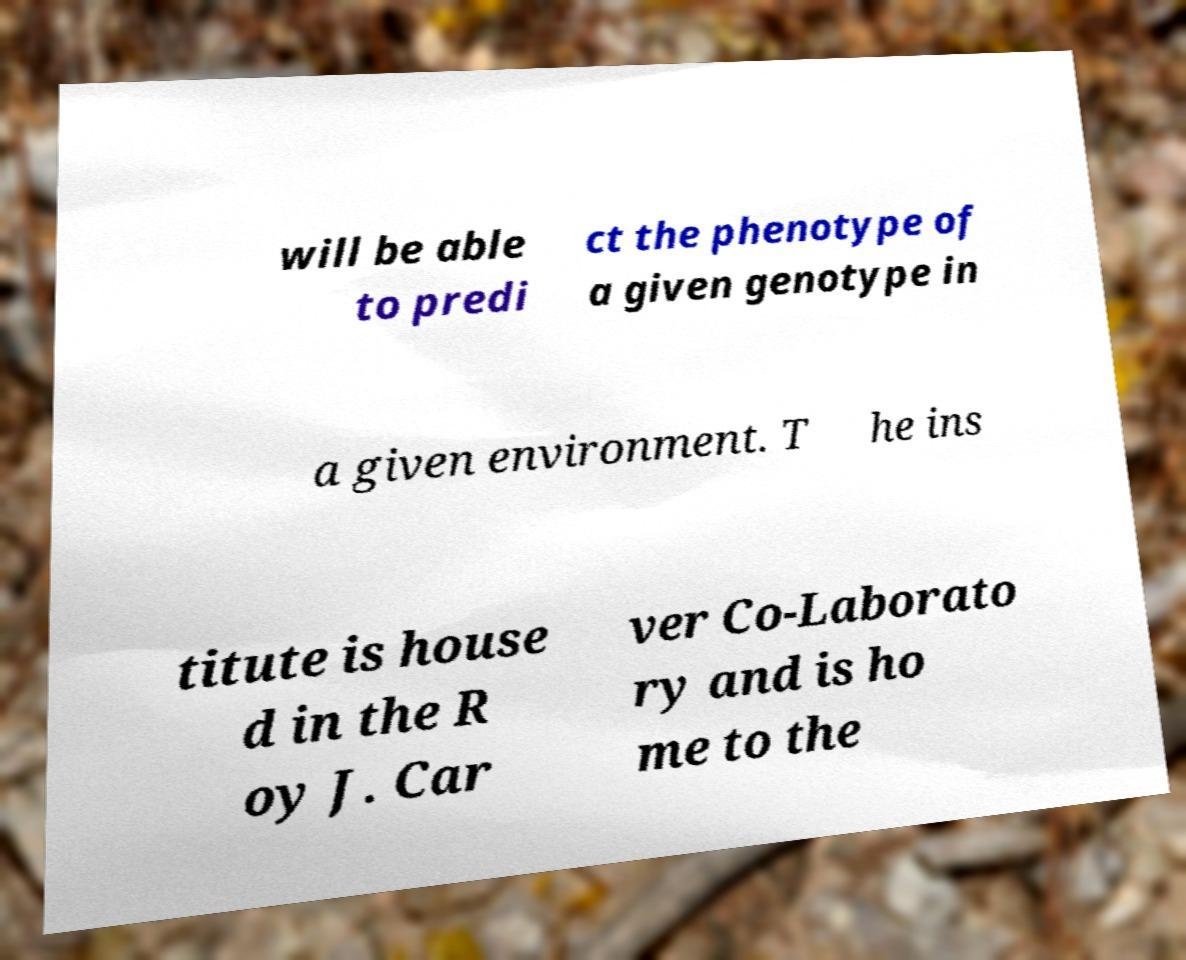Can you accurately transcribe the text from the provided image for me? will be able to predi ct the phenotype of a given genotype in a given environment. T he ins titute is house d in the R oy J. Car ver Co-Laborato ry and is ho me to the 